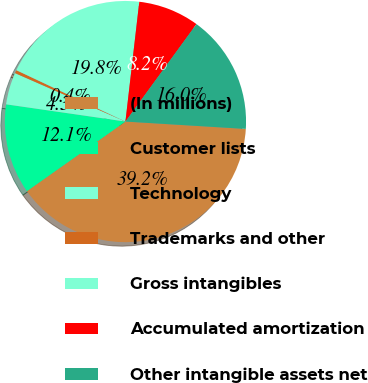Convert chart to OTSL. <chart><loc_0><loc_0><loc_500><loc_500><pie_chart><fcel>(In millions)<fcel>Customer lists<fcel>Technology<fcel>Trademarks and other<fcel>Gross intangibles<fcel>Accumulated amortization<fcel>Other intangible assets net<nl><fcel>39.24%<fcel>12.07%<fcel>4.3%<fcel>0.42%<fcel>19.83%<fcel>8.19%<fcel>15.95%<nl></chart> 